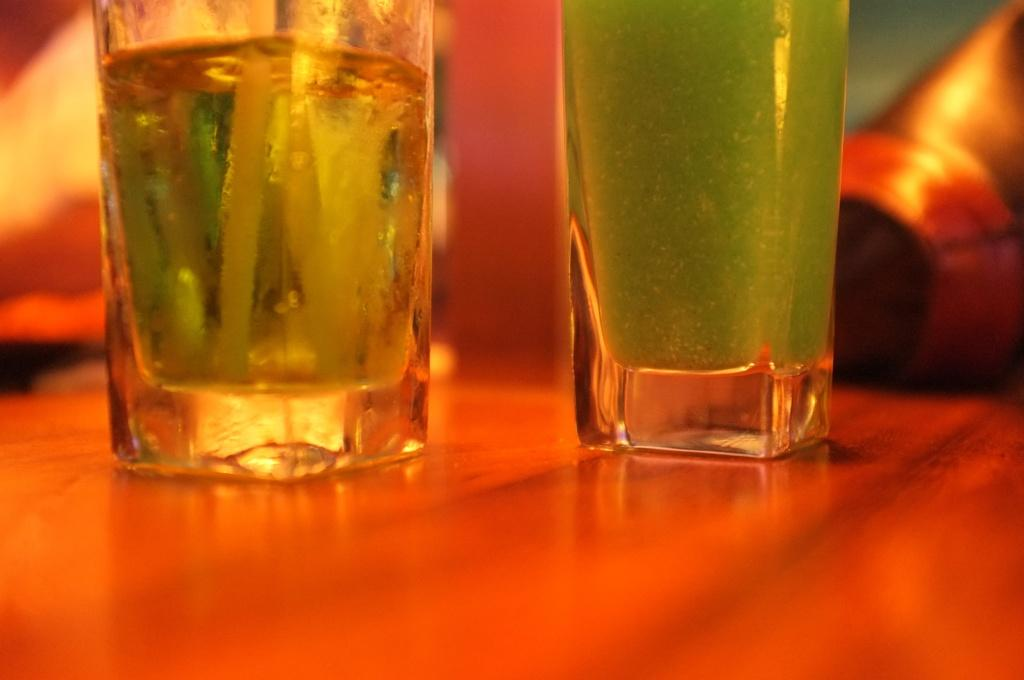What objects are present in the image? There are glasses in the image. What is inside the glasses? The glasses contain beverages. Where are the glasses located? The glasses are placed on a table. What type of polish is being applied to the glasses in the image? There is no indication in the image that any polish is being applied to the glasses. 